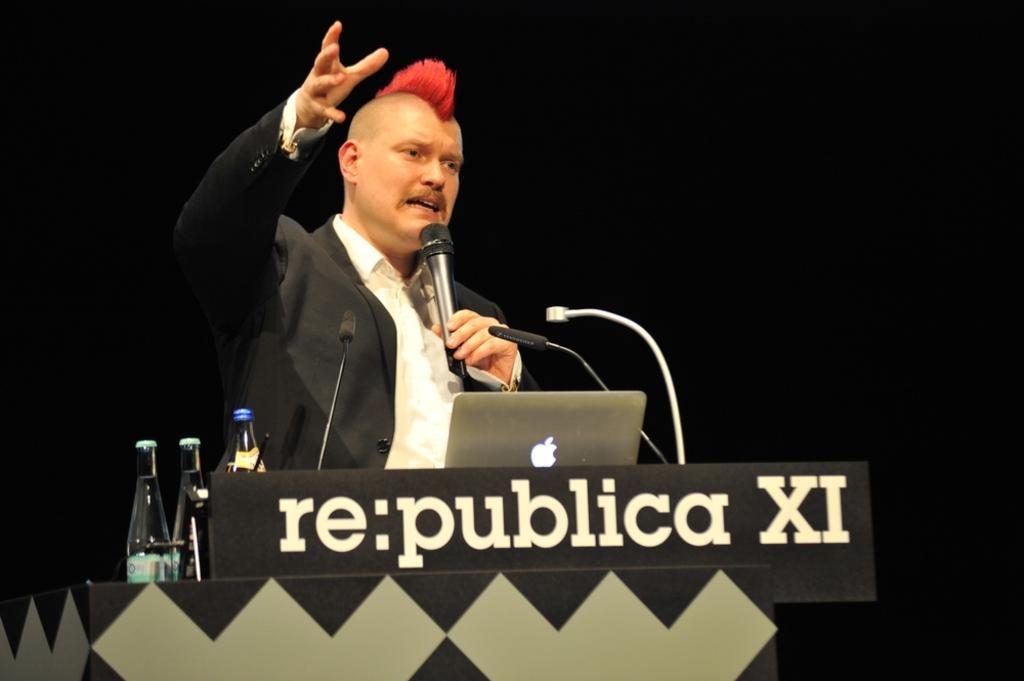Please provide a concise description of this image. In this image there is a podium, a person, mike's, laptop and bottles in the foreground. And the background is black. 